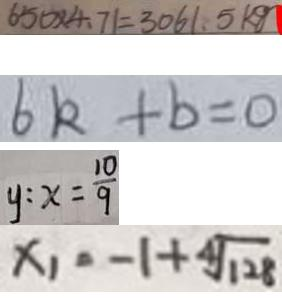<formula> <loc_0><loc_0><loc_500><loc_500>6 5 0 \times 4 . 7 1 = 3 0 6 1 . 5 k g 
 6 k + b = 0 
 y : x = \frac { 1 0 } { 9 } 
 x _ { 1 } = - 1 + \sqrt [ 4 ] { 1 2 8 }</formula> 